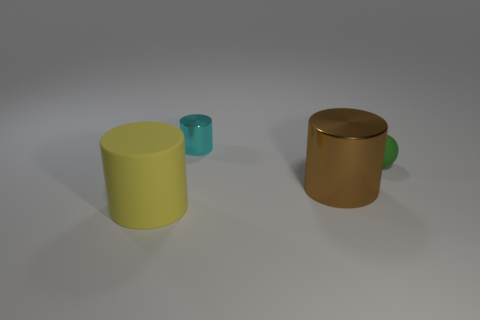What shape is the small green object?
Give a very brief answer. Sphere. Is the material of the tiny green sphere the same as the yellow object?
Provide a short and direct response. Yes. Are there an equal number of yellow cylinders that are behind the rubber cylinder and tiny cyan metal cylinders that are in front of the tiny shiny thing?
Provide a short and direct response. Yes. There is a big thing that is behind the rubber thing left of the brown shiny cylinder; is there a small cylinder on the right side of it?
Keep it short and to the point. No. Does the green thing have the same size as the yellow cylinder?
Ensure brevity in your answer.  No. There is a large cylinder left of the metallic object behind the shiny thing right of the tiny shiny cylinder; what color is it?
Make the answer very short. Yellow. What number of small things are either yellow things or purple metallic cubes?
Keep it short and to the point. 0. Is there another big brown object that has the same shape as the brown shiny thing?
Your answer should be compact. No. Does the yellow object have the same shape as the tiny rubber thing?
Your response must be concise. No. What is the color of the matte ball on the right side of the matte thing that is in front of the matte ball?
Provide a short and direct response. Green. 